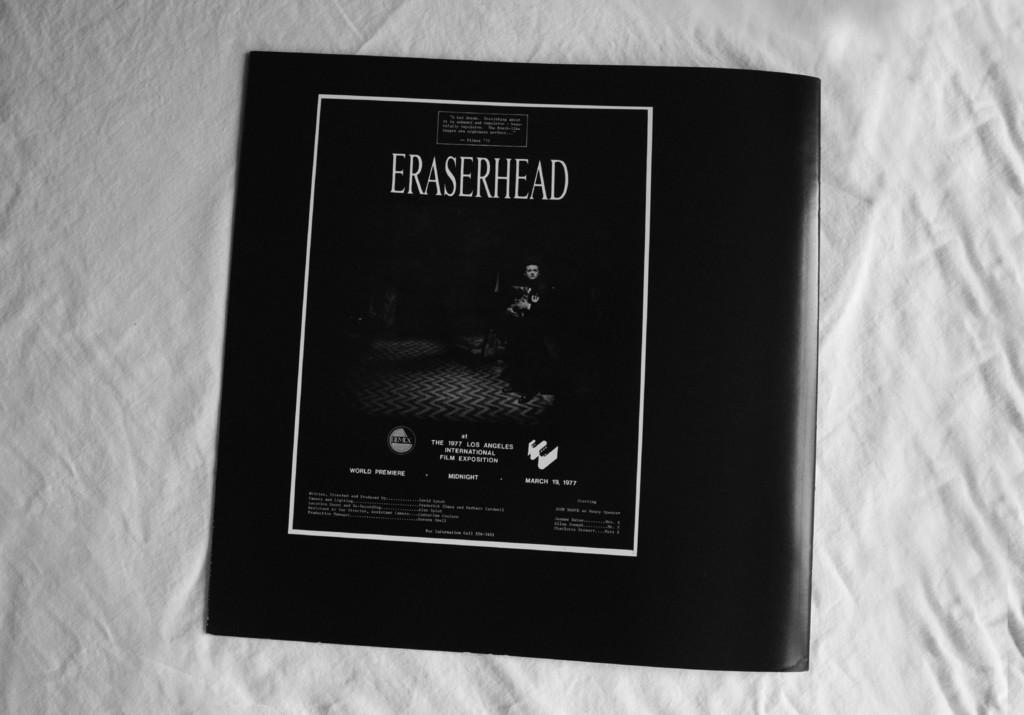<image>
Write a terse but informative summary of the picture. A black book has the title eraserhead written on it. 